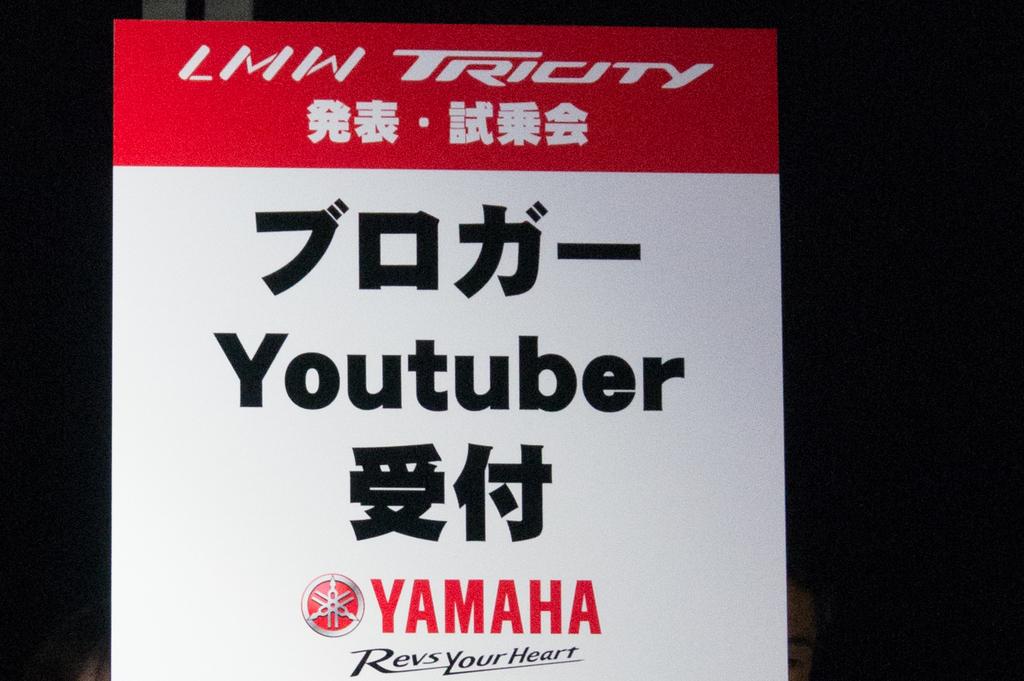What brand is this advertising?
Offer a terse response. Yamaha. 